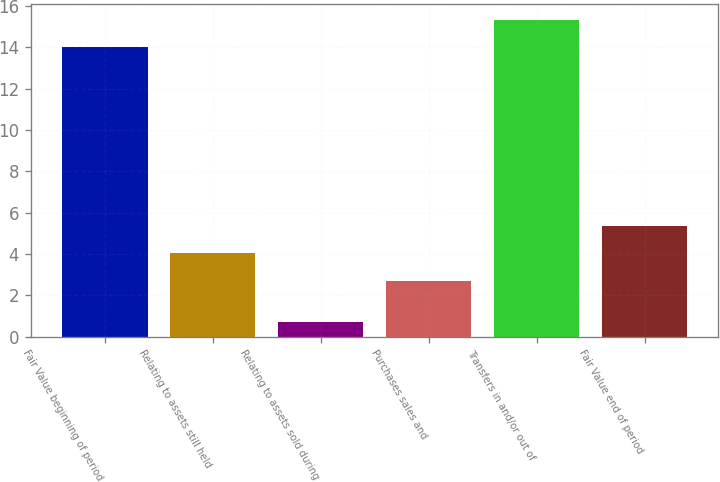<chart> <loc_0><loc_0><loc_500><loc_500><bar_chart><fcel>Fair Value beginning of period<fcel>Relating to assets still held<fcel>Relating to assets sold during<fcel>Purchases sales and<fcel>Transfers in and/or out of<fcel>Fair Value end of period<nl><fcel>14<fcel>4.03<fcel>0.7<fcel>2.7<fcel>15.33<fcel>5.36<nl></chart> 